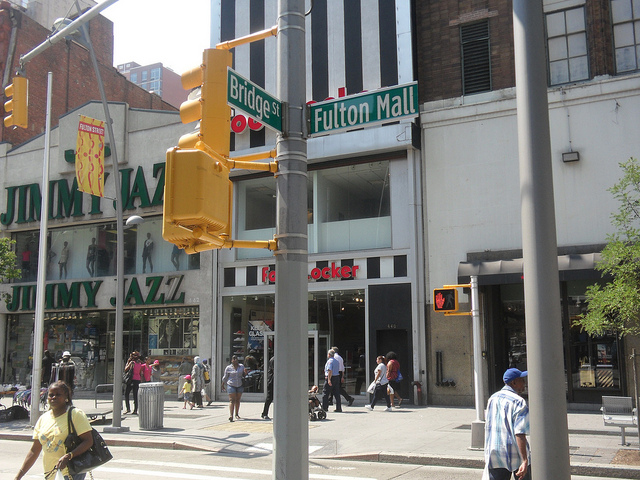Read all the text in this image. Fulton Bridge Fulton Mall JAZZ ker JIMMY JAZ JIMMY 